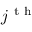Convert formula to latex. <formula><loc_0><loc_0><loc_500><loc_500>j ^ { t h }</formula> 